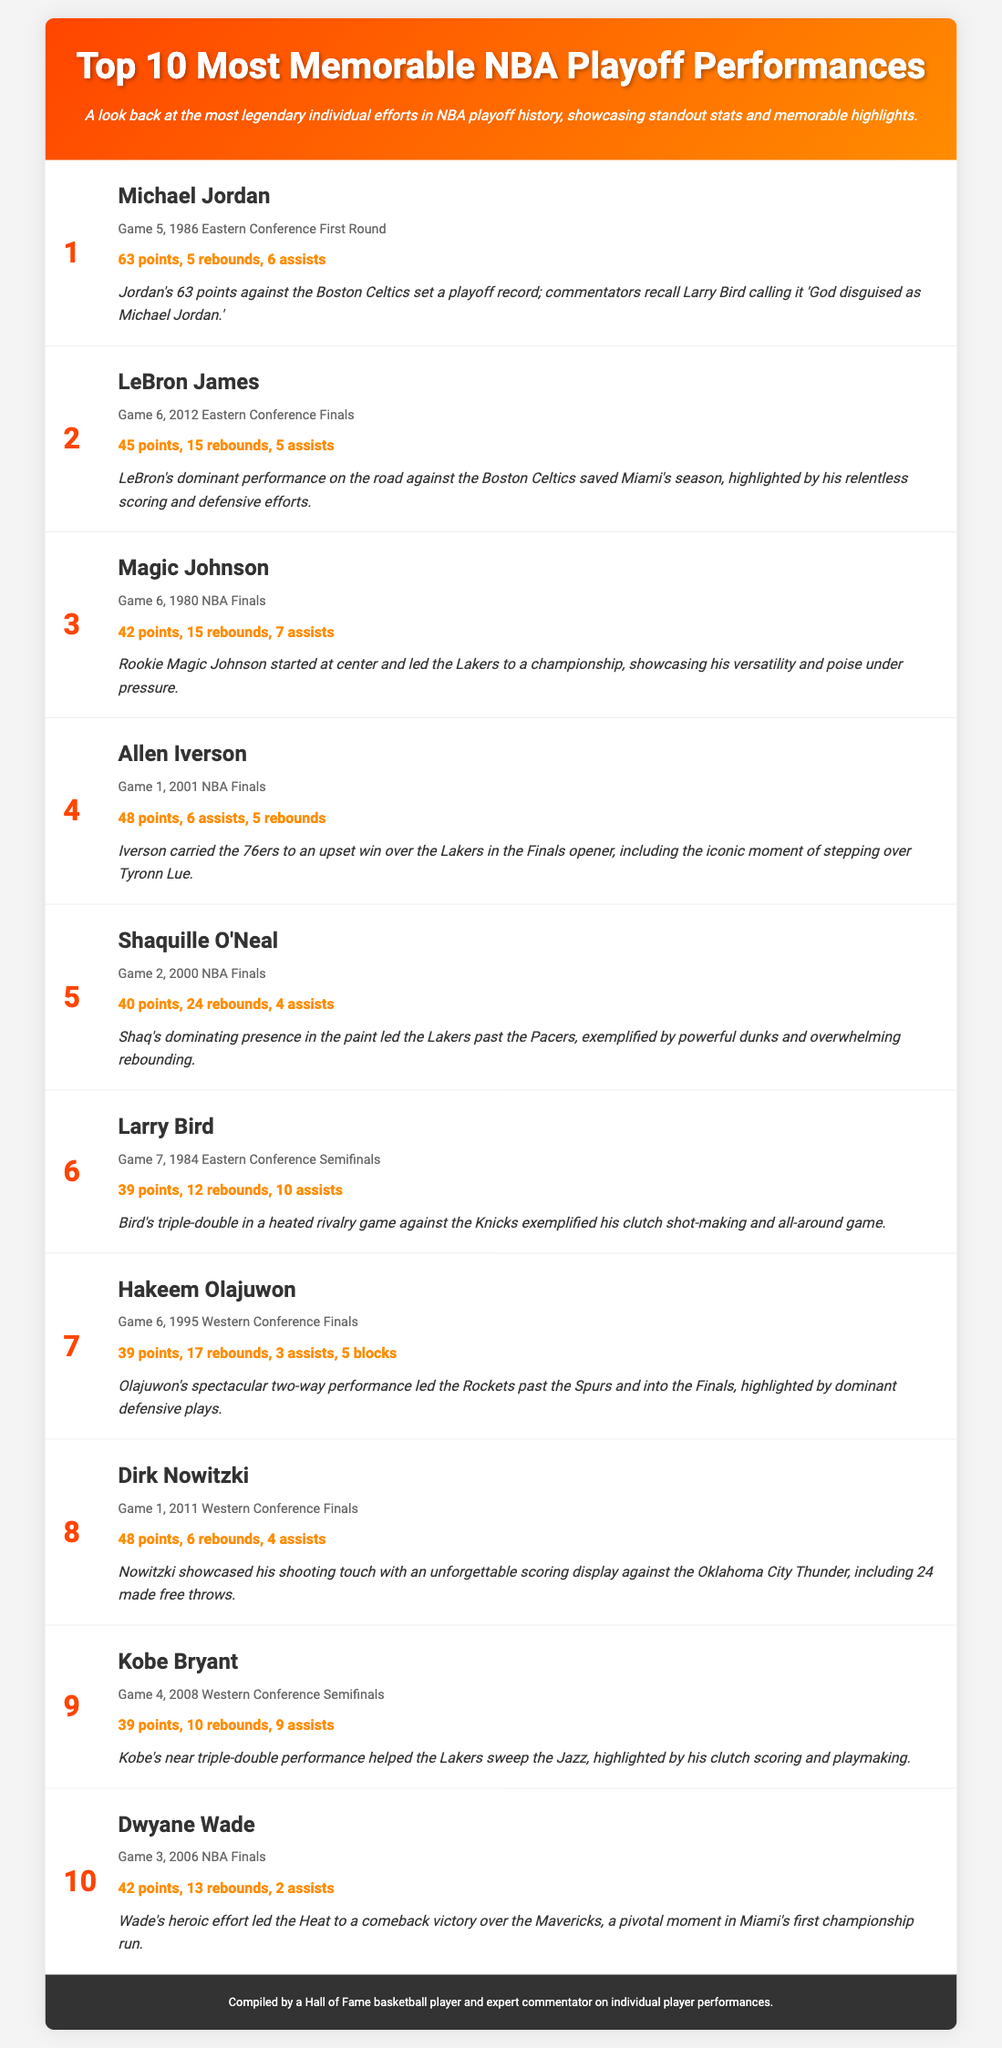What was Michael Jordan's highest point total in a playoff game? Michael Jordan scored 63 points in Game 5 of the 1986 Eastern Conference First Round against the Boston Celtics.
Answer: 63 points Who scored 45 points in the 2012 Eastern Conference Finals? LeBron James scored 45 points in Game 6 during the 2012 Eastern Conference Finals to save Miami's season.
Answer: LeBron James Which player had a triple-double in the 1984 Eastern Conference Semifinals? Larry Bird achieved a triple-double with 39 points, 12 rebounds, and 10 assists in Game 7 against the Knicks.
Answer: Larry Bird What standout achievement did Shaquille O'Neal have in the 2000 NBA Finals? Shaquille O'Neal scored 40 points and grabbed 24 rebounds in Game 2 against the Pacers, showcasing his dominance in the paint.
Answer: 40 points, 24 rebounds How many assists did Allen Iverson record in his memorable 2001 Finals performance? Allen Iverson recorded 6 assists along with 48 points in Game 1 of the 2001 NBA Finals against the Lakers.
Answer: 6 assists Which game featured Dirk Nowitzki scoring 48 points? Dirk Nowitzki scored 48 points in Game 1 of the 2011 Western Conference Finals against the Oklahoma City Thunder.
Answer: Game 1, 2011 Western Conference Finals What memorable moment is associated with Allen Iverson's Game 1 performance? Allen Iverson's performance included the iconic moment of stepping over Tyronn Lue after a basket, underscoring his competitive nature.
Answer: Stepping over Tyronn Lue In which NBA Finals did Dwyane Wade score 42 points? Dwyane Wade scored 42 points in Game 3 of the 2006 NBA Finals against the Mavericks, which was pivotal for Miami's championship run.
Answer: Game 3, 2006 NBA Finals What was the overall theme of the list infographic? The infographic highlights the most legendary individual efforts in NBA playoff history, showcasing standout stats and memorable highlights.
Answer: Memorable playoff performances 